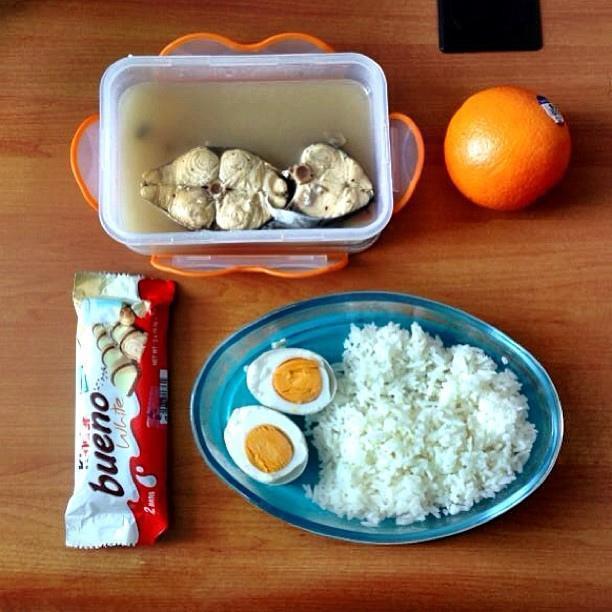How many bowls are there?
Give a very brief answer. 2. 